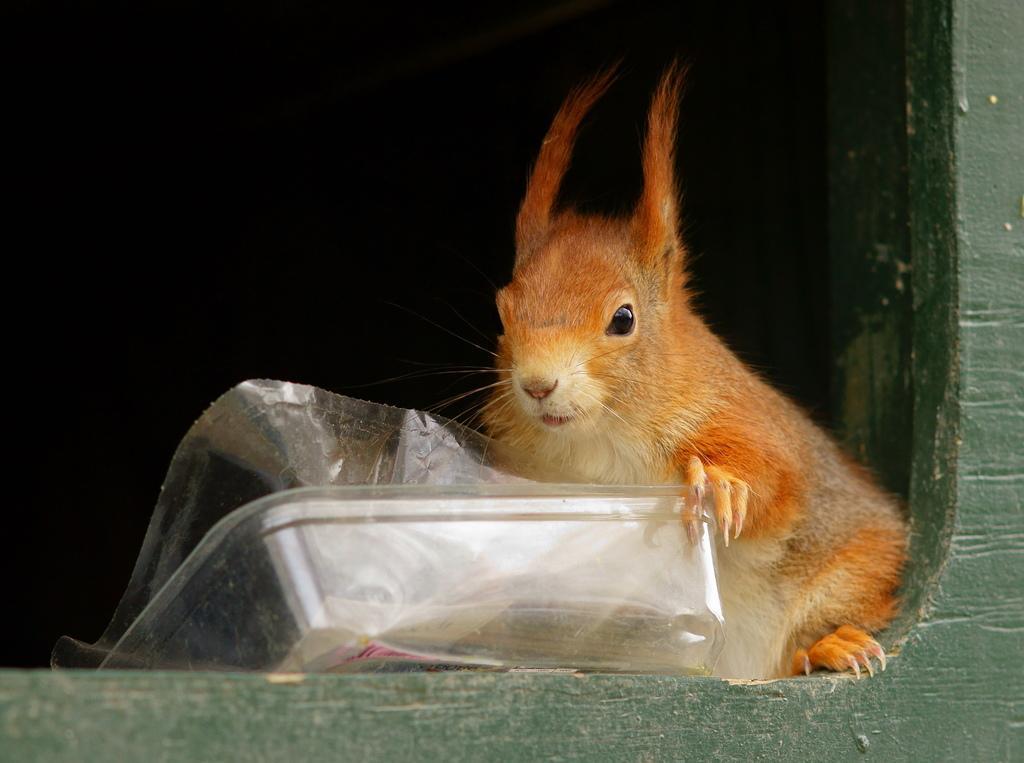How would you summarize this image in a sentence or two? There is a squirrel and a plastic wrapper in the center of the image, it seems like a wooden border at the bottom side. 